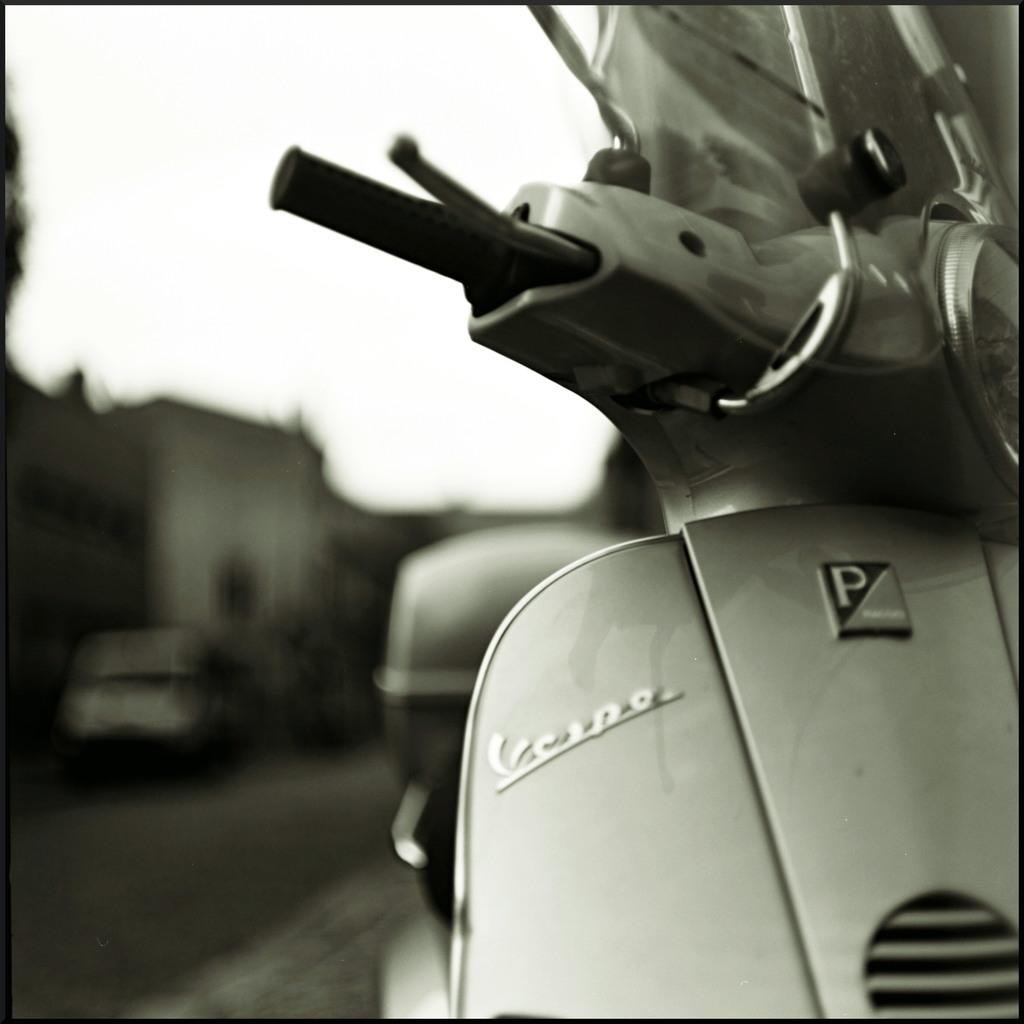What type of vehicle is in the image? There is a grey colored scooter in the image. Where is the scooter located? The scooter is on the road. What is behind the scooter in the image? There is a van behind the scooter in the image. What can be seen in the distance in the image? There are buildings visible in the background of the image, but they appear blurry. Can you see any toads hopping around in the field in the image? There is no field or toads present in the image; it features a scooter on the road with a van behind it and blurry buildings in the background. 